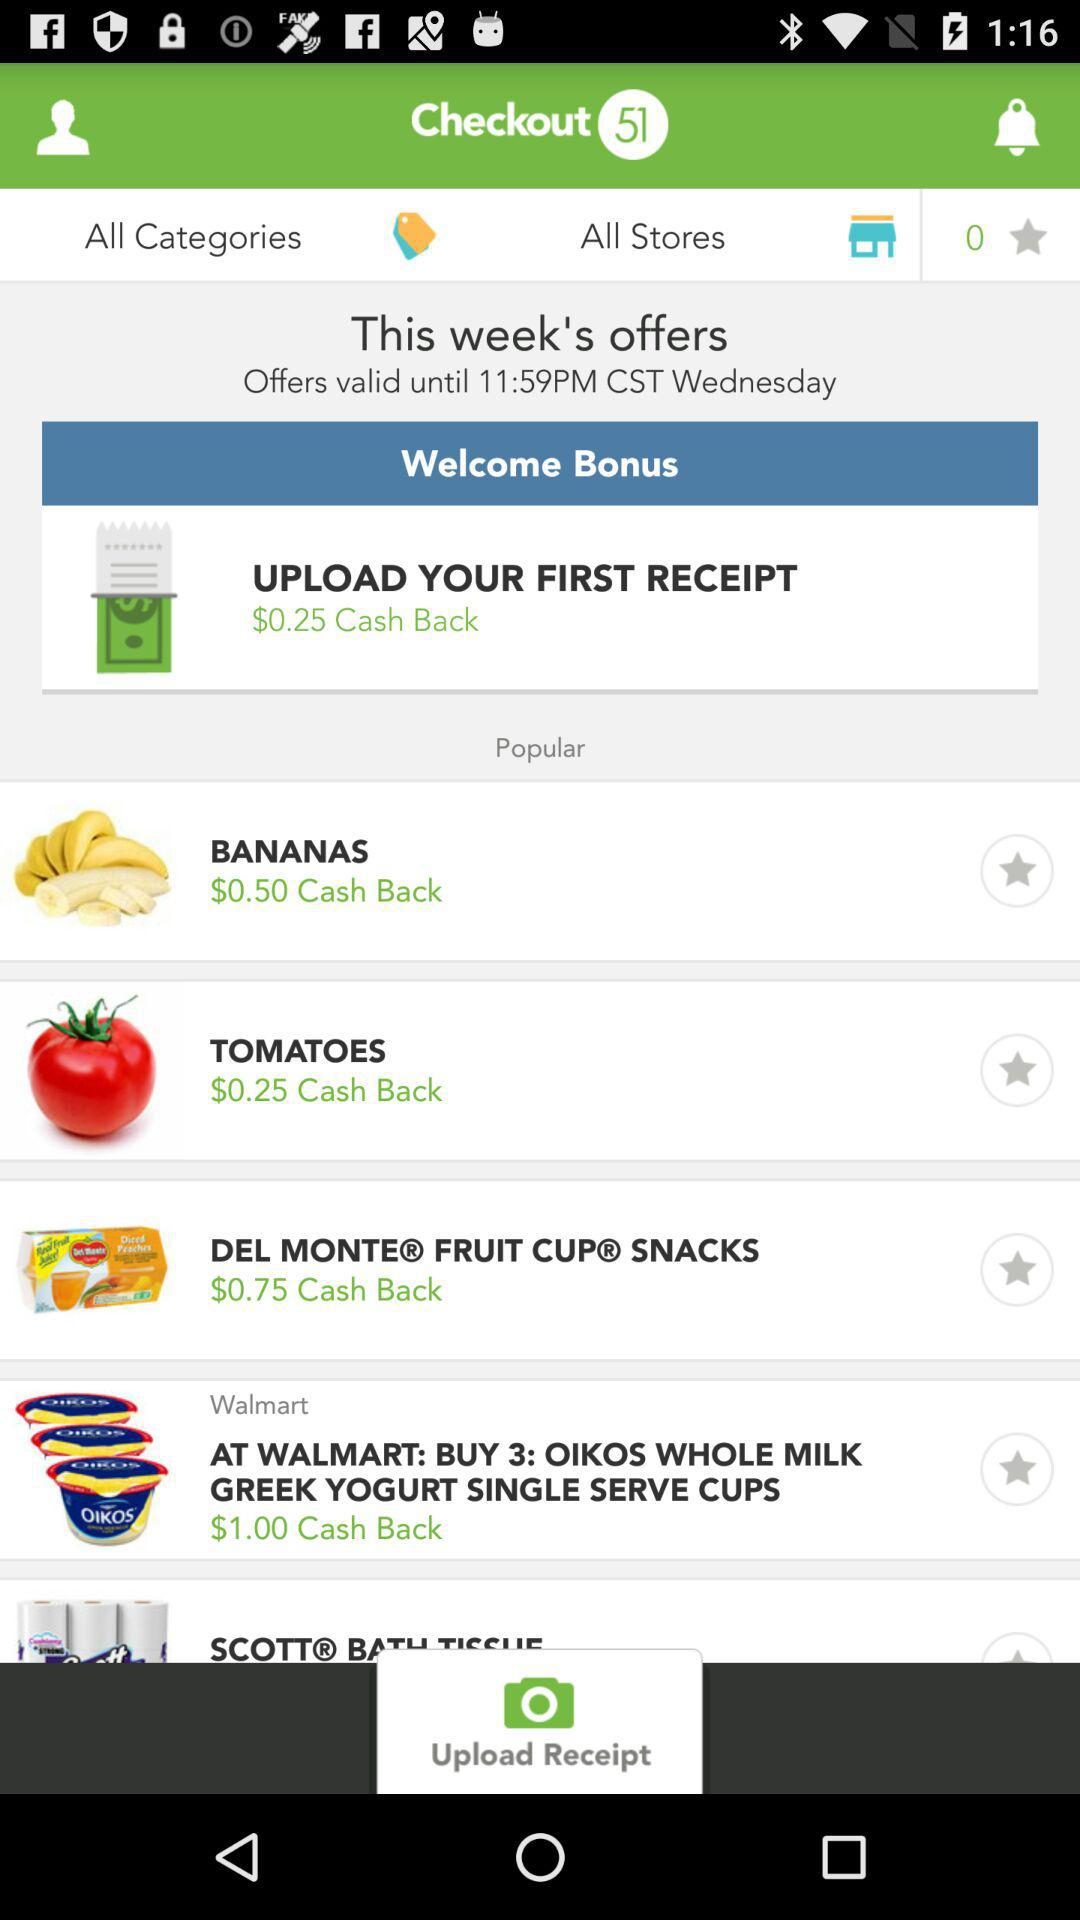How many cash back offers are there on the screen?
Answer the question using a single word or phrase. 5 